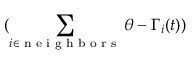Convert formula to latex. <formula><loc_0><loc_0><loc_500><loc_500>( \sum _ { i \in n e i g h b o r s } \theta - \Gamma _ { i } ( t ) )</formula> 